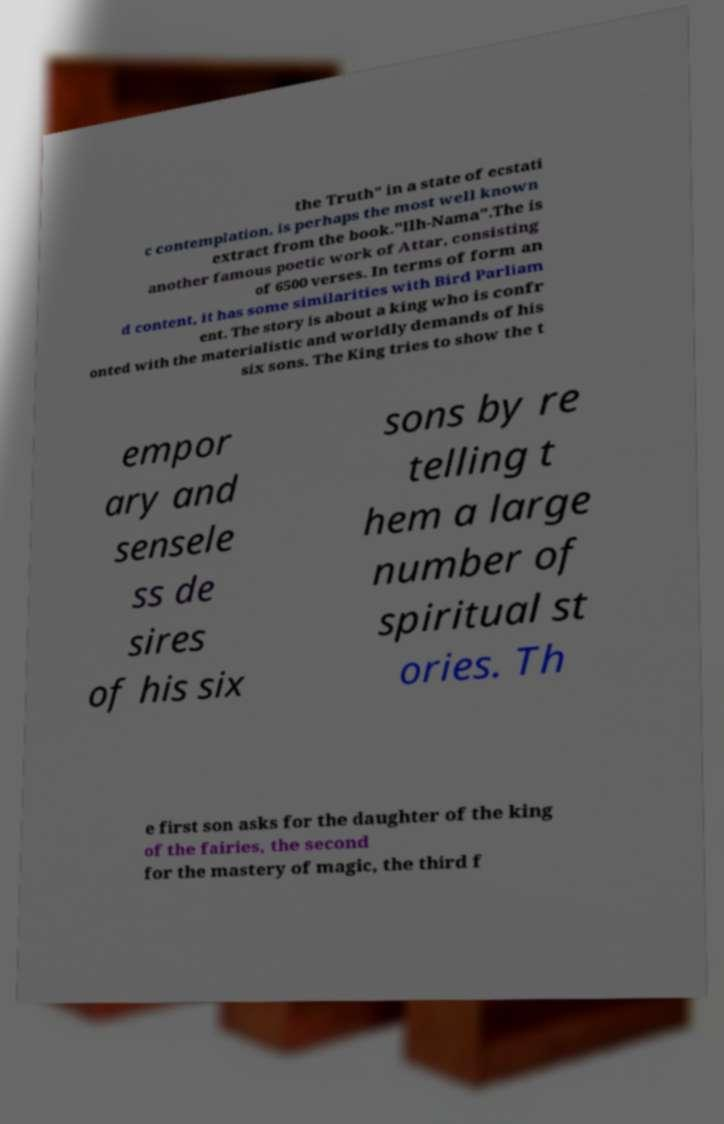Could you assist in decoding the text presented in this image and type it out clearly? the Truth" in a state of ecstati c contemplation, is perhaps the most well known extract from the book."Ilh-Nama".The is another famous poetic work of Attar, consisting of 6500 verses. In terms of form an d content, it has some similarities with Bird Parliam ent. The story is about a king who is confr onted with the materialistic and worldly demands of his six sons. The King tries to show the t empor ary and sensele ss de sires of his six sons by re telling t hem a large number of spiritual st ories. Th e first son asks for the daughter of the king of the fairies, the second for the mastery of magic, the third f 